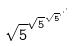<formula> <loc_0><loc_0><loc_500><loc_500>\sqrt { 5 } ^ { \sqrt { 5 } ^ { \sqrt { 5 } ^ { \cdot ^ { \cdot ^ { \cdot } } } } }</formula> 